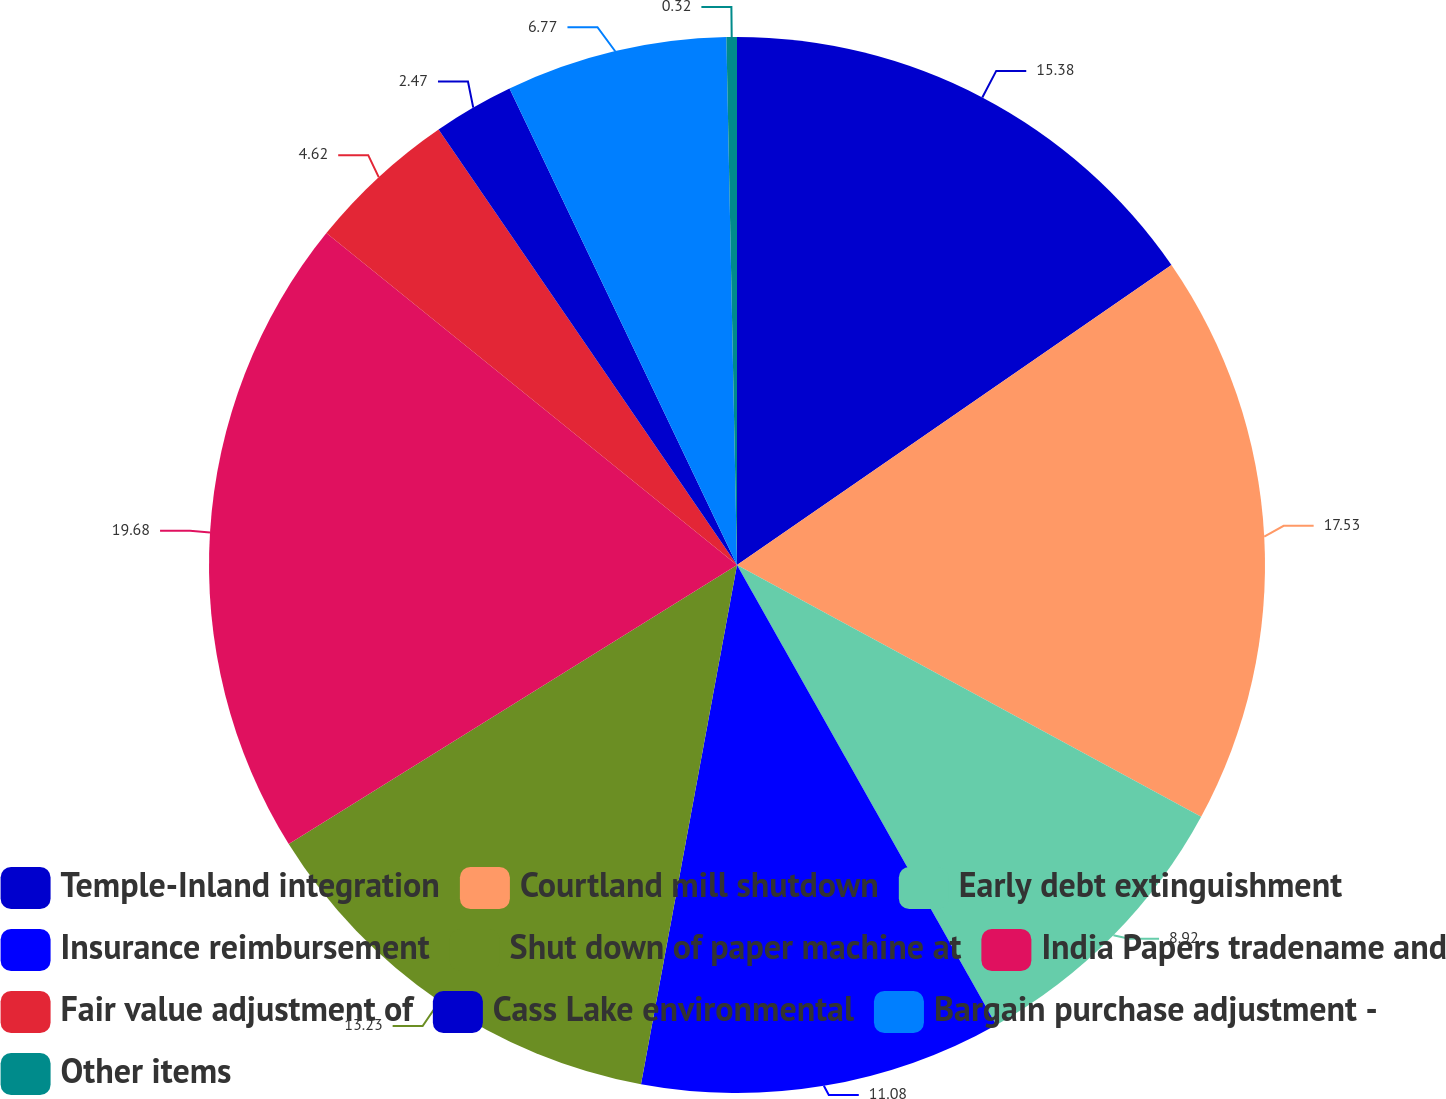<chart> <loc_0><loc_0><loc_500><loc_500><pie_chart><fcel>Temple-Inland integration<fcel>Courtland mill shutdown<fcel>Early debt extinguishment<fcel>Insurance reimbursement<fcel>Shut down of paper machine at<fcel>India Papers tradename and<fcel>Fair value adjustment of<fcel>Cass Lake environmental<fcel>Bargain purchase adjustment -<fcel>Other items<nl><fcel>15.38%<fcel>17.53%<fcel>8.92%<fcel>11.08%<fcel>13.23%<fcel>19.68%<fcel>4.62%<fcel>2.47%<fcel>6.77%<fcel>0.32%<nl></chart> 